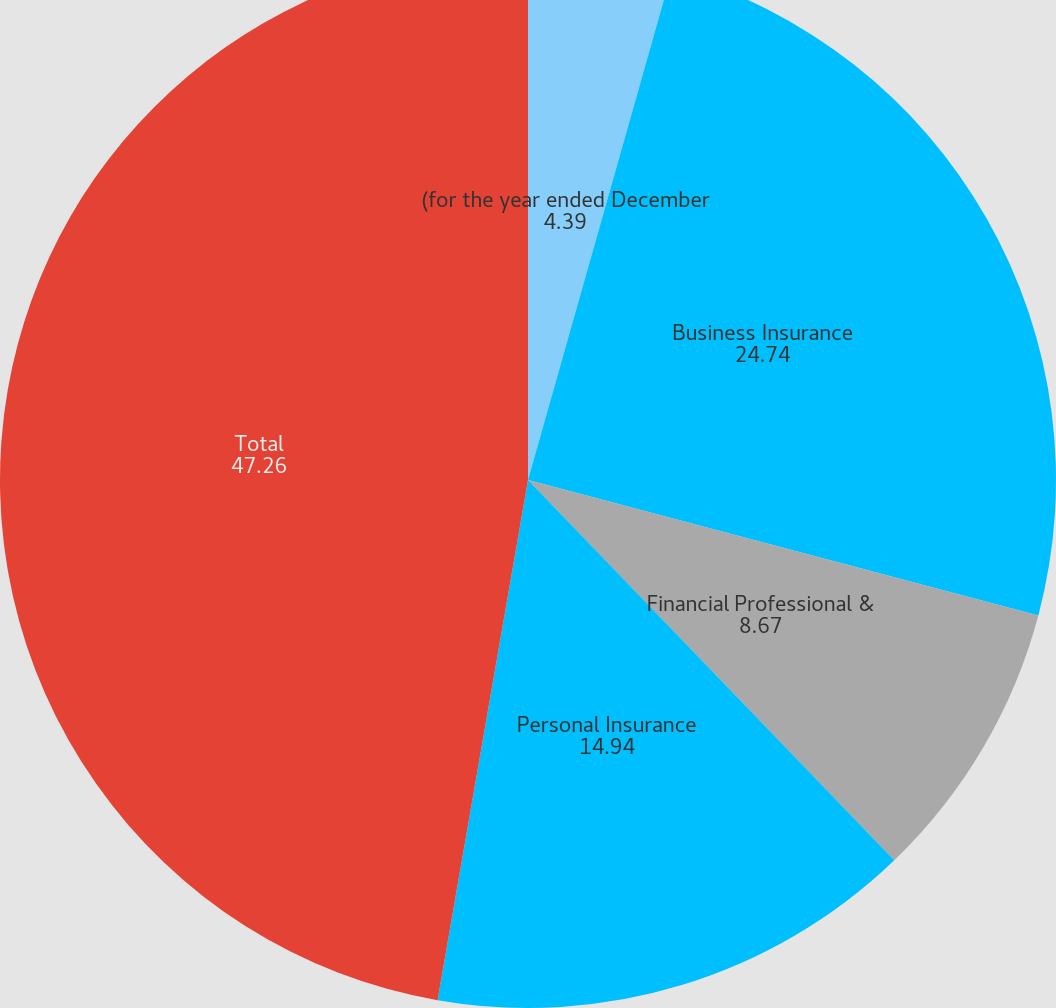Convert chart to OTSL. <chart><loc_0><loc_0><loc_500><loc_500><pie_chart><fcel>(for the year ended December<fcel>Business Insurance<fcel>Financial Professional &<fcel>Personal Insurance<fcel>Total<nl><fcel>4.39%<fcel>24.74%<fcel>8.67%<fcel>14.94%<fcel>47.26%<nl></chart> 